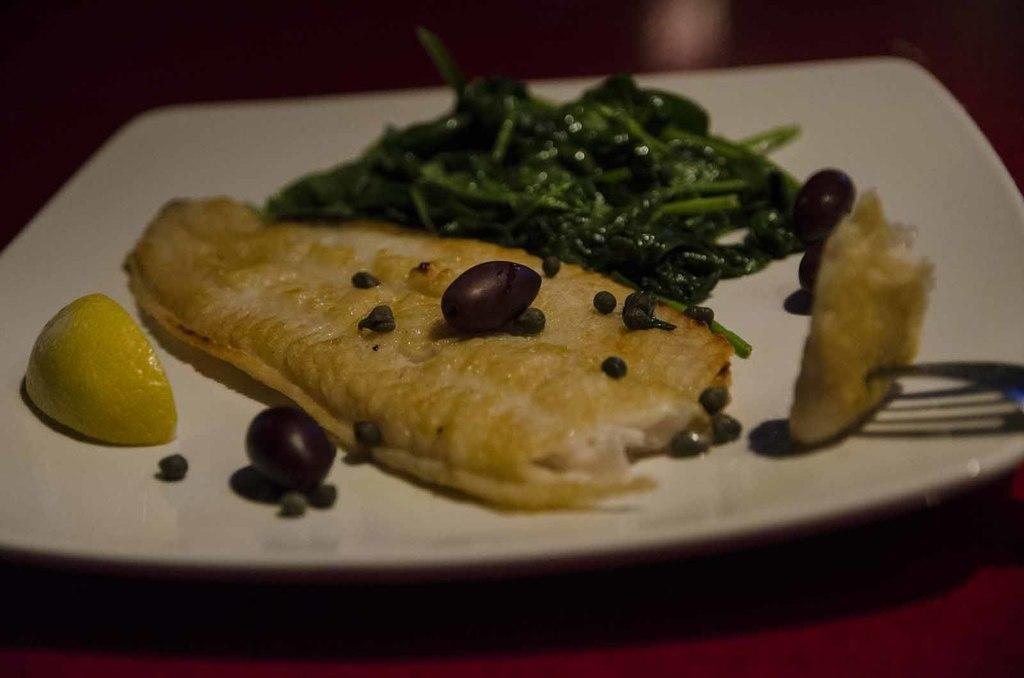What type of food items can be seen in the image? There are cooked food items in the image. How are the food items arranged or presented? The food items are served on a plate. How many cattle can be seen grazing in the image? There are no cattle present in the image; it features cooked food items served on a plate. What type of ticket is visible in the image? There is no ticket present in the image. 